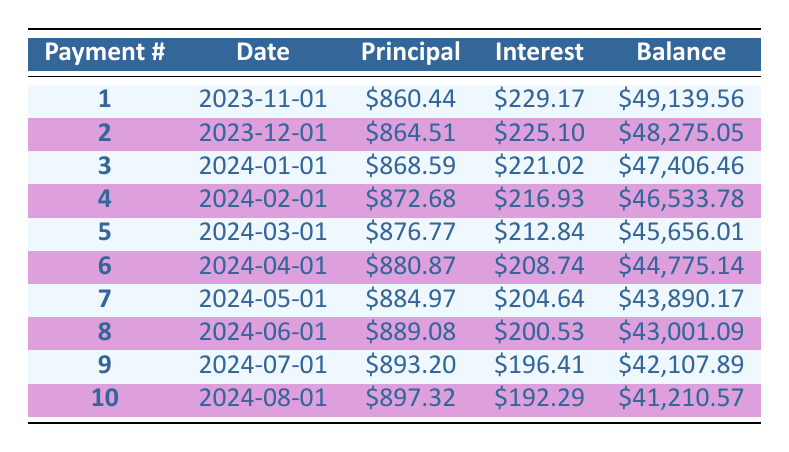What is the principal payment for the first payment? The first payment number is 1, and the principal payment for that entry is clearly stated as 860.44.
Answer: 860.44 What is the total interest paid in the first four payments? To find the total interest paid in the first four payments, we sum the interest payments for those entries: 229.17 + 225.10 + 221.02 + 216.93 = 892.22.
Answer: 892.22 Is the interest payment for the second payment higher than that for the first payment? The interest payment for the first payment is 229.17, and for the second, it is 225.10. Since 229.17 is greater than 225.10, the statement is true.
Answer: Yes What is the remaining balance after the fifth payment? For the fifth payment, the remaining balance is given as 45,656.01.
Answer: 45,656.01 What is the average principal payment for the first ten payments? The principal payments for the first ten payments are 860.44, 864.51, 868.59, 872.68, 876.77, 880.87, 884.97, 889.08, 893.20, and 897.32. Their sum is 8,675.43, and there are 10 payments, so the average is 8,675.43 / 10 = 867.54.
Answer: 867.54 How much has the remaining balance decreased after the sixth payment compared to the first payment? The remaining balance after the first payment is 49,139.56, and after the sixth payment it is 44,775.14. The difference is 49,139.56 - 44,775.14 = 4,364.42.
Answer: 4,364.42 Is the principal payment increasing for every subsequent payment? By examining the principal payments, which are: 860.44, 864.51, 868.59, 872.68, 876.77, 880.87, 884.97, 889.08, 893.20, and 897.32, we can see that each value is greater than the previous value, confirming the pattern.
Answer: Yes What is the total amount paid after the first three months? The total amount paid in the first three months consists of the monthly payments: 966.44 for each month. For three months, the total is 966.44 * 3 = 2,899.32.
Answer: 2,899.32 What is the difference between the highest and lowest principal payments made in the first ten payments? The highest principal payment is 897.32 (the tenth payment) and the lowest is 860.44 (the first payment). The difference is 897.32 - 860.44 = 36.88.
Answer: 36.88 